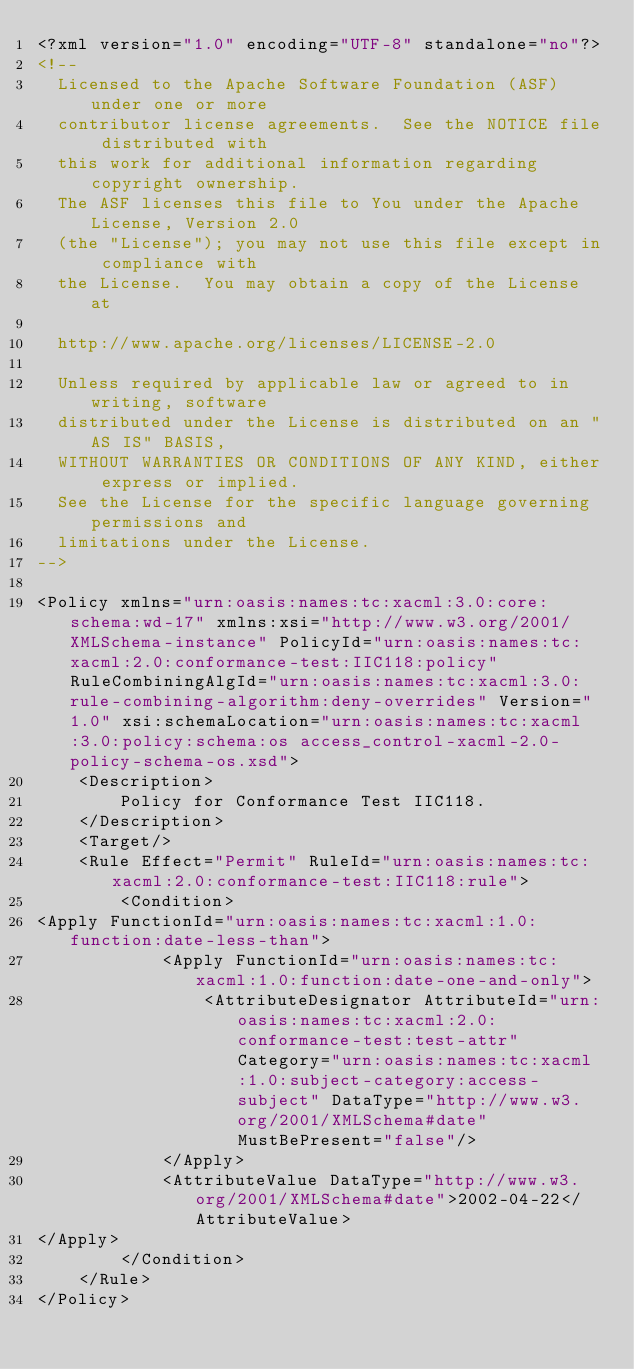Convert code to text. <code><loc_0><loc_0><loc_500><loc_500><_XML_><?xml version="1.0" encoding="UTF-8" standalone="no"?>
<!--
  Licensed to the Apache Software Foundation (ASF) under one or more
  contributor license agreements.  See the NOTICE file distributed with
  this work for additional information regarding copyright ownership.
  The ASF licenses this file to You under the Apache License, Version 2.0
  (the "License"); you may not use this file except in compliance with
  the License.  You may obtain a copy of the License at

  http://www.apache.org/licenses/LICENSE-2.0

  Unless required by applicable law or agreed to in writing, software
  distributed under the License is distributed on an "AS IS" BASIS,
  WITHOUT WARRANTIES OR CONDITIONS OF ANY KIND, either express or implied.
  See the License for the specific language governing permissions and
  limitations under the License.
-->

<Policy xmlns="urn:oasis:names:tc:xacml:3.0:core:schema:wd-17" xmlns:xsi="http://www.w3.org/2001/XMLSchema-instance" PolicyId="urn:oasis:names:tc:xacml:2.0:conformance-test:IIC118:policy" RuleCombiningAlgId="urn:oasis:names:tc:xacml:3.0:rule-combining-algorithm:deny-overrides" Version="1.0" xsi:schemaLocation="urn:oasis:names:tc:xacml:3.0:policy:schema:os access_control-xacml-2.0-policy-schema-os.xsd">
    <Description>
        Policy for Conformance Test IIC118.
    </Description>
    <Target/>
    <Rule Effect="Permit" RuleId="urn:oasis:names:tc:xacml:2.0:conformance-test:IIC118:rule">
        <Condition>
<Apply FunctionId="urn:oasis:names:tc:xacml:1.0:function:date-less-than">
            <Apply FunctionId="urn:oasis:names:tc:xacml:1.0:function:date-one-and-only">
                <AttributeDesignator AttributeId="urn:oasis:names:tc:xacml:2.0:conformance-test:test-attr" Category="urn:oasis:names:tc:xacml:1.0:subject-category:access-subject" DataType="http://www.w3.org/2001/XMLSchema#date" MustBePresent="false"/>
            </Apply>
            <AttributeValue DataType="http://www.w3.org/2001/XMLSchema#date">2002-04-22</AttributeValue>
</Apply>
        </Condition>
    </Rule>
</Policy>
</code> 